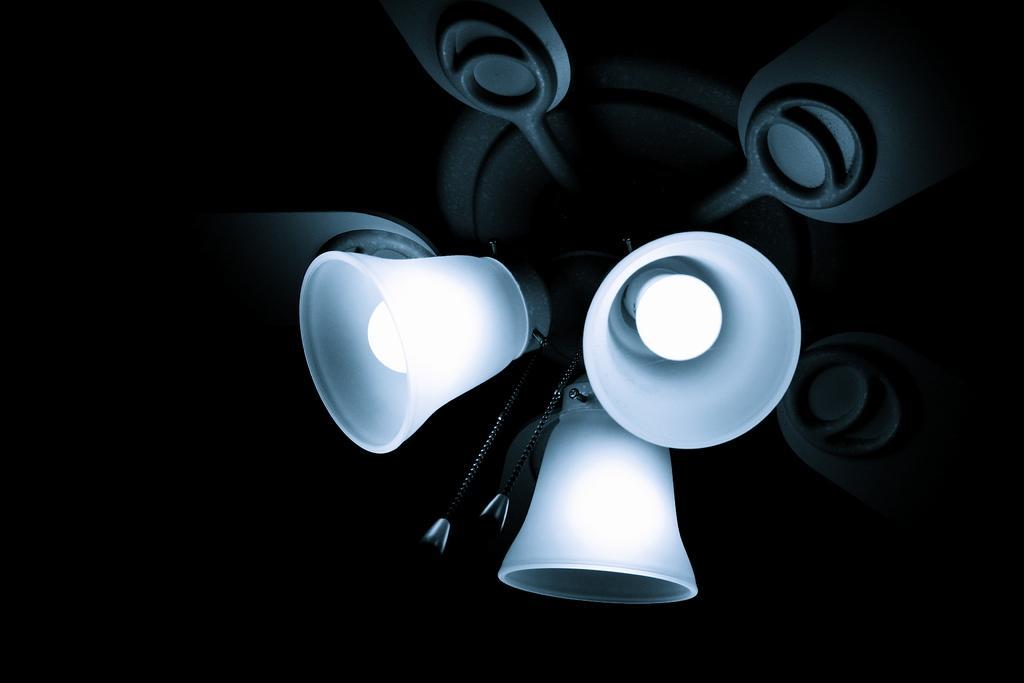Could you give a brief overview of what you see in this image? In this image there are lambs to the ceiling. The background is dark. 